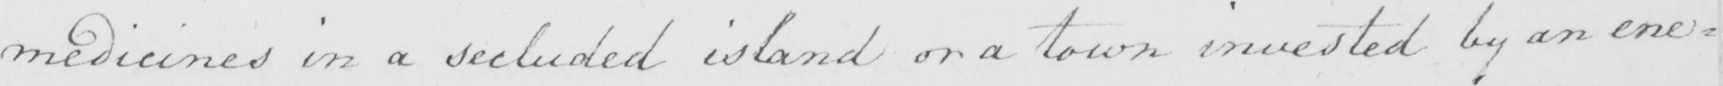Can you tell me what this handwritten text says? medicines in a secluded island or a town invested by an ene= 